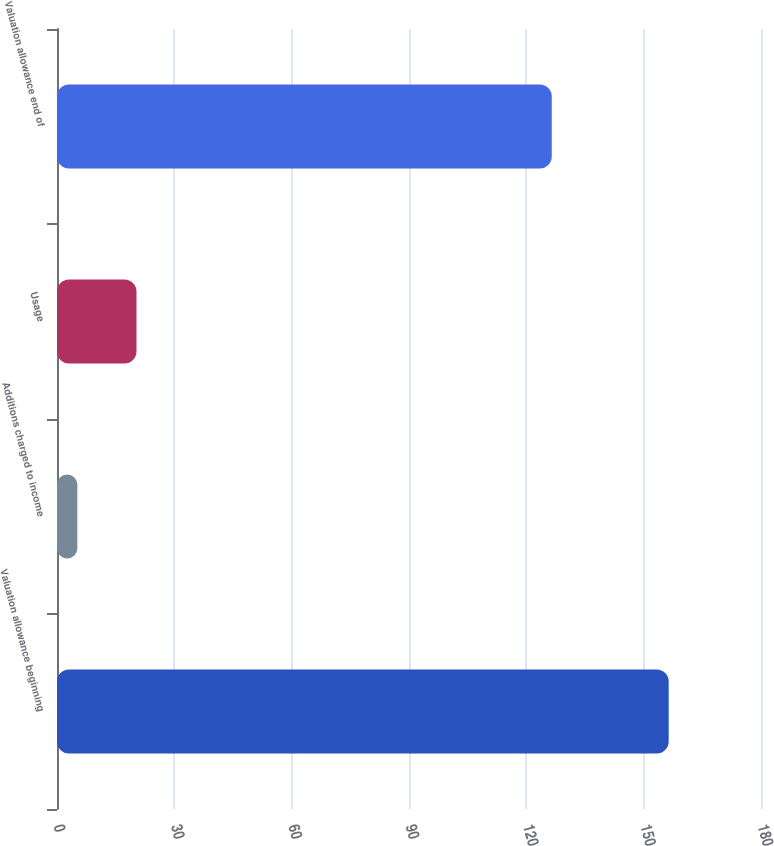<chart> <loc_0><loc_0><loc_500><loc_500><bar_chart><fcel>Valuation allowance beginning<fcel>Additions charged to income<fcel>Usage<fcel>Valuation allowance end of<nl><fcel>156.4<fcel>5.2<fcel>20.32<fcel>126.5<nl></chart> 